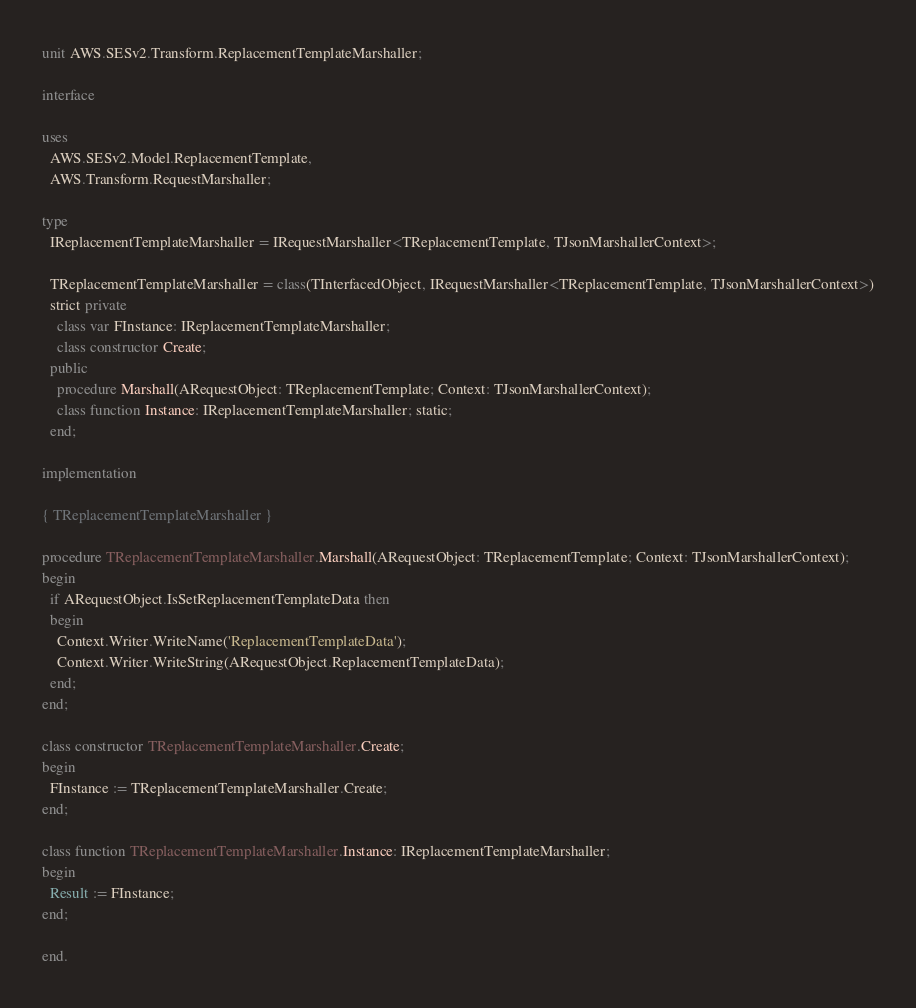Convert code to text. <code><loc_0><loc_0><loc_500><loc_500><_Pascal_>unit AWS.SESv2.Transform.ReplacementTemplateMarshaller;

interface

uses
  AWS.SESv2.Model.ReplacementTemplate, 
  AWS.Transform.RequestMarshaller;

type
  IReplacementTemplateMarshaller = IRequestMarshaller<TReplacementTemplate, TJsonMarshallerContext>;
  
  TReplacementTemplateMarshaller = class(TInterfacedObject, IRequestMarshaller<TReplacementTemplate, TJsonMarshallerContext>)
  strict private
    class var FInstance: IReplacementTemplateMarshaller;
    class constructor Create;
  public
    procedure Marshall(ARequestObject: TReplacementTemplate; Context: TJsonMarshallerContext);
    class function Instance: IReplacementTemplateMarshaller; static;
  end;
  
implementation

{ TReplacementTemplateMarshaller }

procedure TReplacementTemplateMarshaller.Marshall(ARequestObject: TReplacementTemplate; Context: TJsonMarshallerContext);
begin
  if ARequestObject.IsSetReplacementTemplateData then
  begin
    Context.Writer.WriteName('ReplacementTemplateData');
    Context.Writer.WriteString(ARequestObject.ReplacementTemplateData);
  end;
end;

class constructor TReplacementTemplateMarshaller.Create;
begin
  FInstance := TReplacementTemplateMarshaller.Create;
end;

class function TReplacementTemplateMarshaller.Instance: IReplacementTemplateMarshaller;
begin
  Result := FInstance;
end;

end.
</code> 